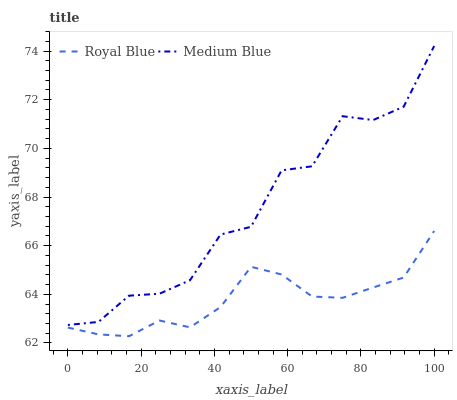Does Royal Blue have the minimum area under the curve?
Answer yes or no. Yes. Does Medium Blue have the maximum area under the curve?
Answer yes or no. Yes. Does Medium Blue have the minimum area under the curve?
Answer yes or no. No. Is Royal Blue the smoothest?
Answer yes or no. Yes. Is Medium Blue the roughest?
Answer yes or no. Yes. Is Medium Blue the smoothest?
Answer yes or no. No. Does Royal Blue have the lowest value?
Answer yes or no. Yes. Does Medium Blue have the lowest value?
Answer yes or no. No. Does Medium Blue have the highest value?
Answer yes or no. Yes. Is Royal Blue less than Medium Blue?
Answer yes or no. Yes. Is Medium Blue greater than Royal Blue?
Answer yes or no. Yes. Does Royal Blue intersect Medium Blue?
Answer yes or no. No. 